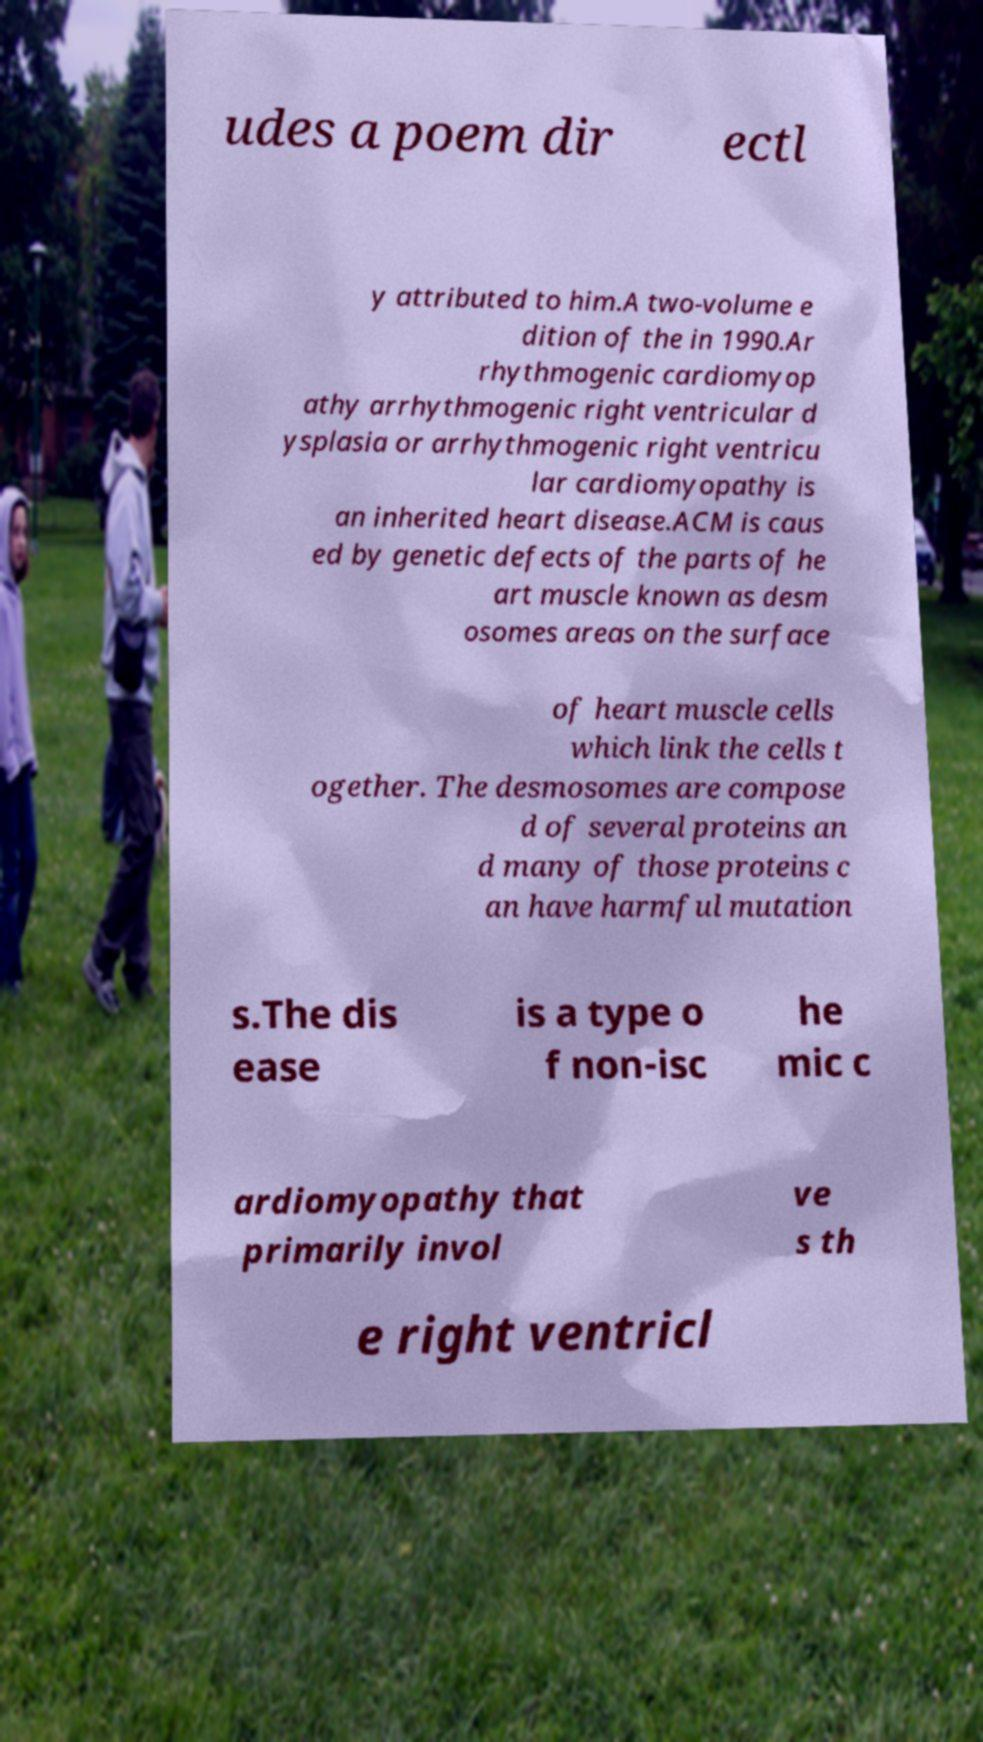Could you extract and type out the text from this image? udes a poem dir ectl y attributed to him.A two-volume e dition of the in 1990.Ar rhythmogenic cardiomyop athy arrhythmogenic right ventricular d ysplasia or arrhythmogenic right ventricu lar cardiomyopathy is an inherited heart disease.ACM is caus ed by genetic defects of the parts of he art muscle known as desm osomes areas on the surface of heart muscle cells which link the cells t ogether. The desmosomes are compose d of several proteins an d many of those proteins c an have harmful mutation s.The dis ease is a type o f non-isc he mic c ardiomyopathy that primarily invol ve s th e right ventricl 